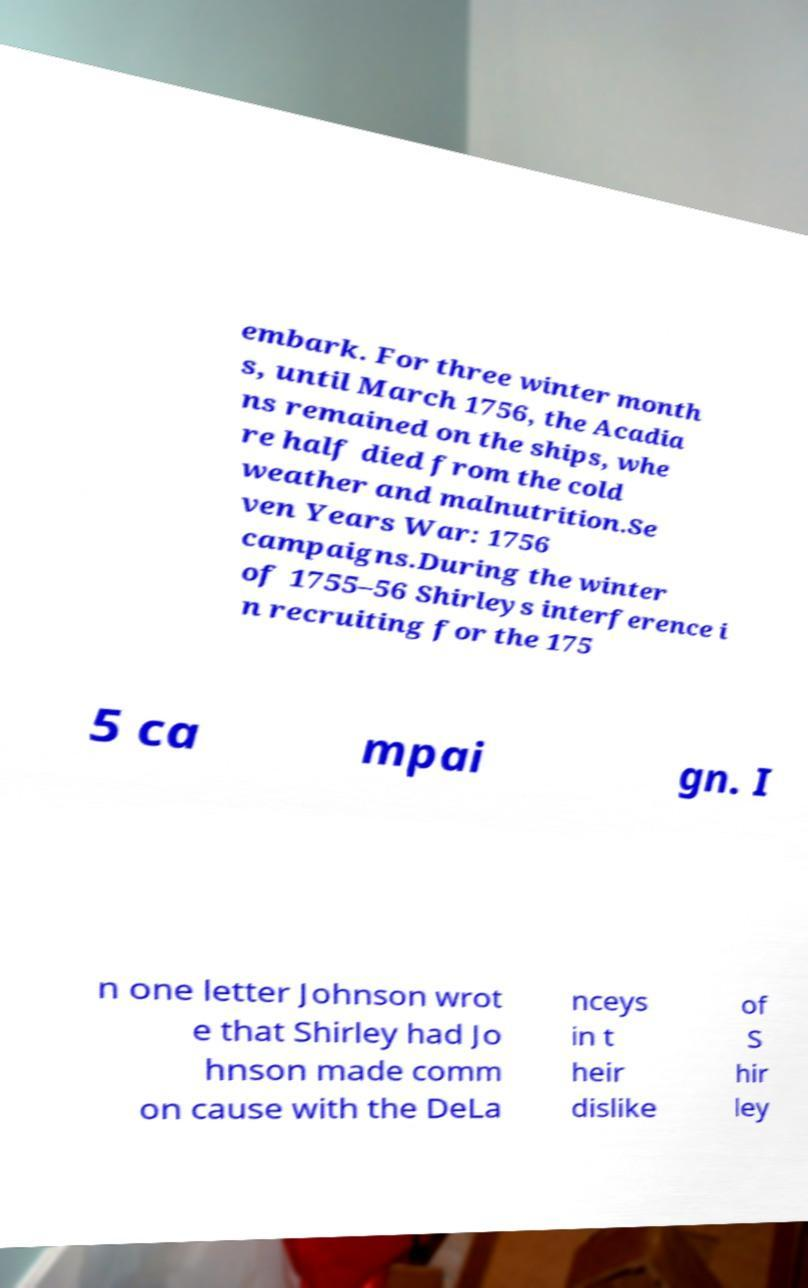There's text embedded in this image that I need extracted. Can you transcribe it verbatim? embark. For three winter month s, until March 1756, the Acadia ns remained on the ships, whe re half died from the cold weather and malnutrition.Se ven Years War: 1756 campaigns.During the winter of 1755–56 Shirleys interference i n recruiting for the 175 5 ca mpai gn. I n one letter Johnson wrot e that Shirley had Jo hnson made comm on cause with the DeLa nceys in t heir dislike of S hir ley 